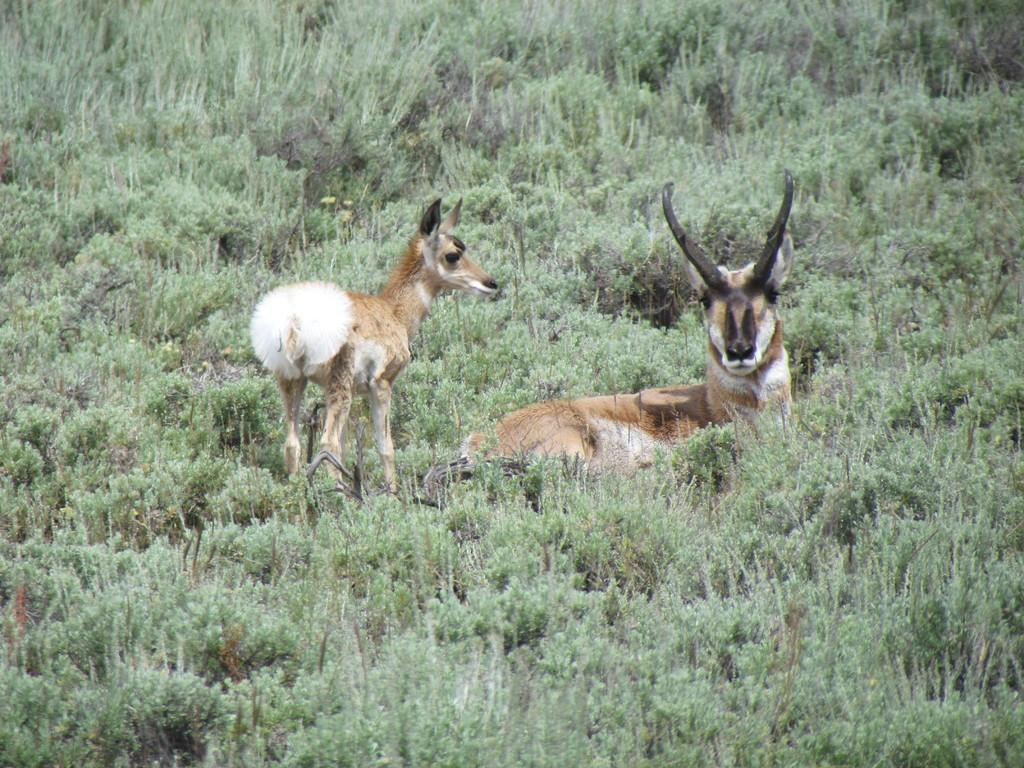How many deer are present in the image? There are 2 deer in the image. Where are the deer located? The deer are on the grass. What type of suit is the deer wearing in the image? There is no suit present in the image, as deer do not wear clothing. 